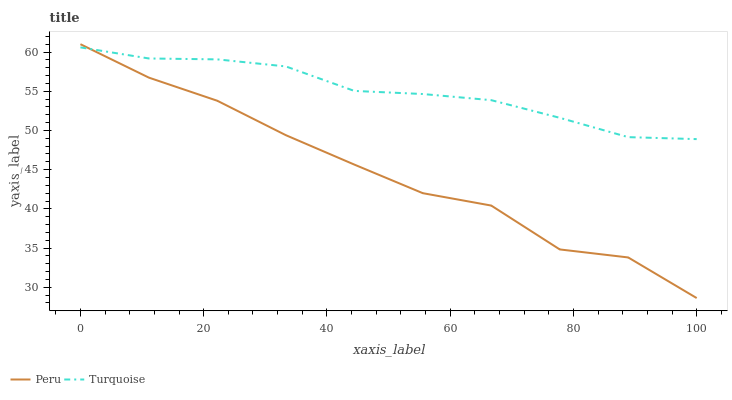Does Peru have the minimum area under the curve?
Answer yes or no. Yes. Does Turquoise have the maximum area under the curve?
Answer yes or no. Yes. Does Peru have the maximum area under the curve?
Answer yes or no. No. Is Turquoise the smoothest?
Answer yes or no. Yes. Is Peru the roughest?
Answer yes or no. Yes. Is Peru the smoothest?
Answer yes or no. No. Does Peru have the lowest value?
Answer yes or no. Yes. Does Peru have the highest value?
Answer yes or no. Yes. Does Peru intersect Turquoise?
Answer yes or no. Yes. Is Peru less than Turquoise?
Answer yes or no. No. Is Peru greater than Turquoise?
Answer yes or no. No. 